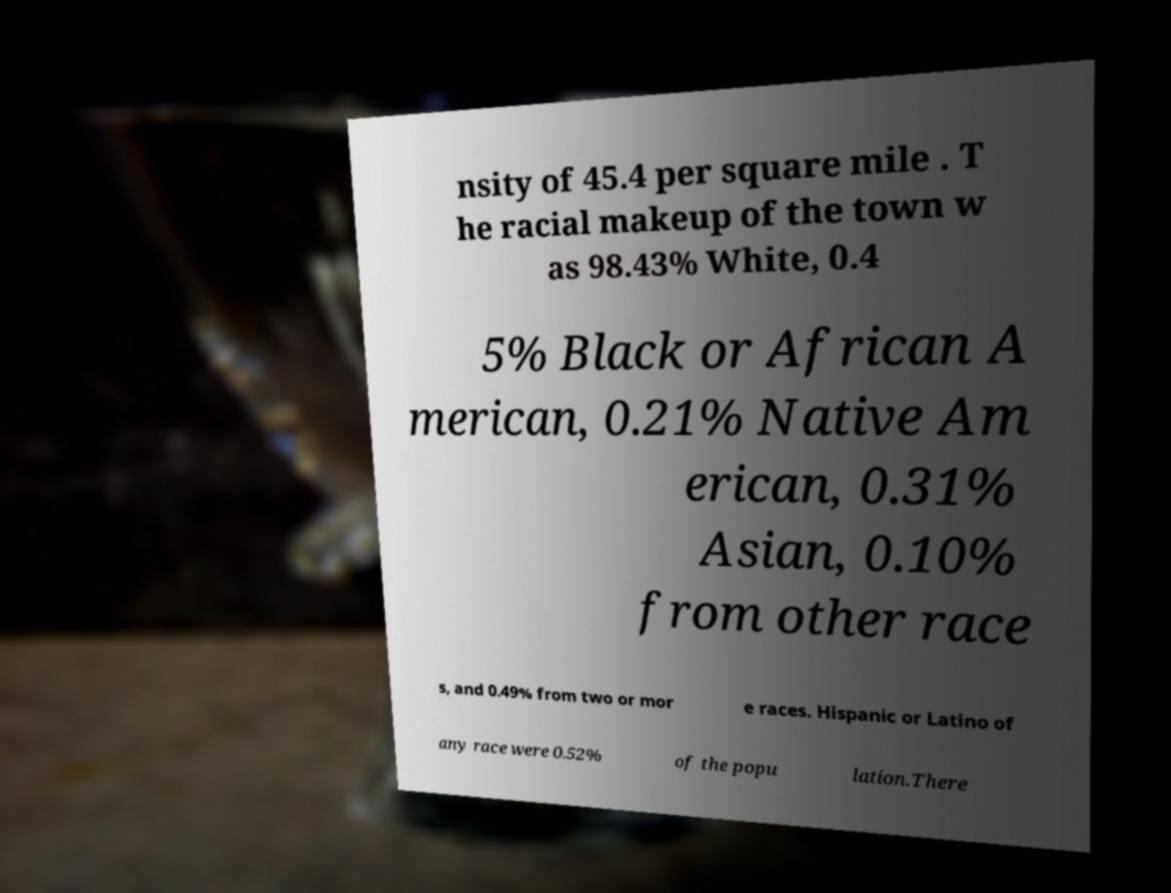Could you assist in decoding the text presented in this image and type it out clearly? nsity of 45.4 per square mile . T he racial makeup of the town w as 98.43% White, 0.4 5% Black or African A merican, 0.21% Native Am erican, 0.31% Asian, 0.10% from other race s, and 0.49% from two or mor e races. Hispanic or Latino of any race were 0.52% of the popu lation.There 